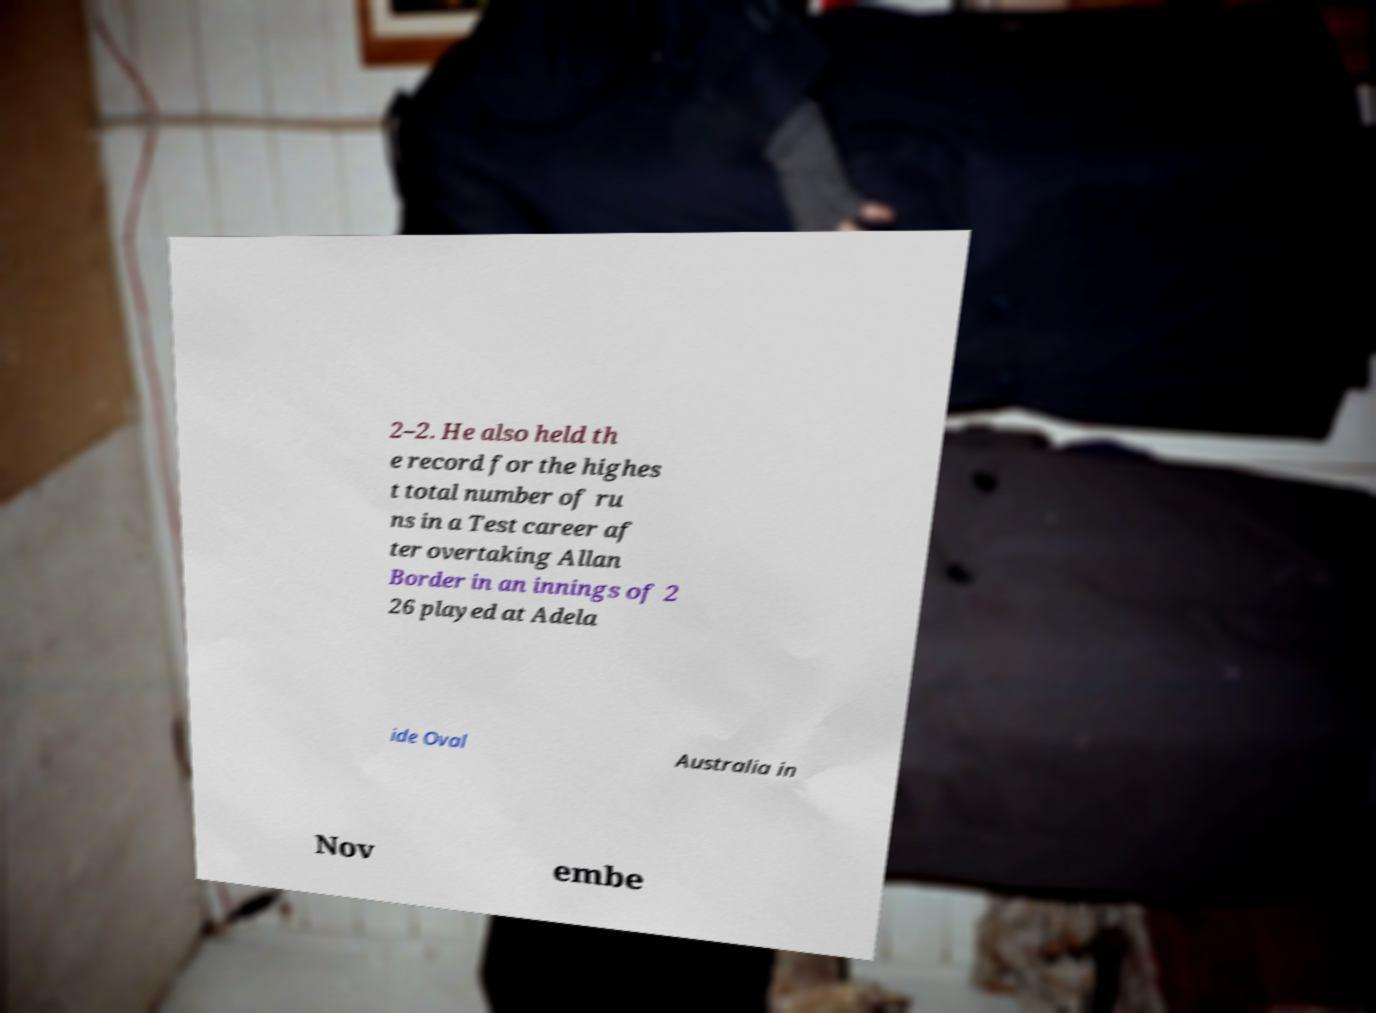Could you assist in decoding the text presented in this image and type it out clearly? 2–2. He also held th e record for the highes t total number of ru ns in a Test career af ter overtaking Allan Border in an innings of 2 26 played at Adela ide Oval Australia in Nov embe 